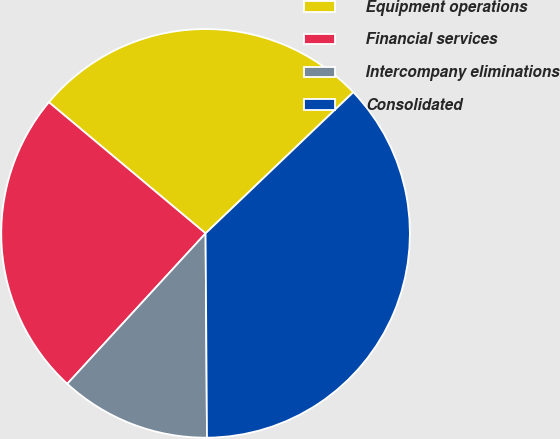Convert chart. <chart><loc_0><loc_0><loc_500><loc_500><pie_chart><fcel>Equipment operations<fcel>Financial services<fcel>Intercompany eliminations<fcel>Consolidated<nl><fcel>26.77%<fcel>24.26%<fcel>11.94%<fcel>37.02%<nl></chart> 